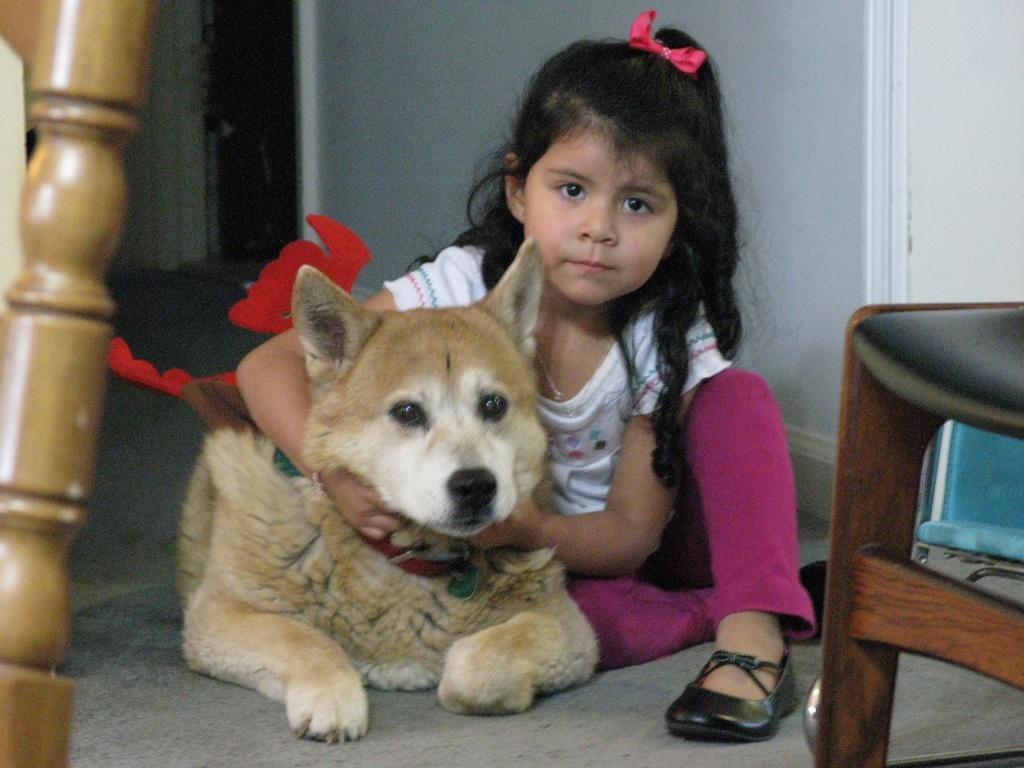Please provide a concise description of this image. In this picture we can see a girl holding dog's neck with her hand inside to her and in the background we can see wall, door and in front of them we can see chair, wooden stick. 